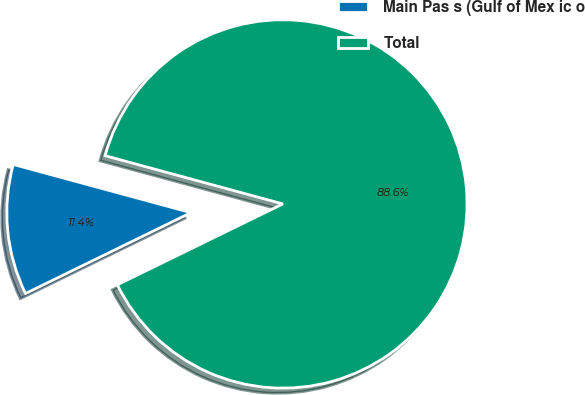<chart> <loc_0><loc_0><loc_500><loc_500><pie_chart><fcel>Main Pas s (Gulf of Mex ic o<fcel>Total<nl><fcel>11.45%<fcel>88.55%<nl></chart> 